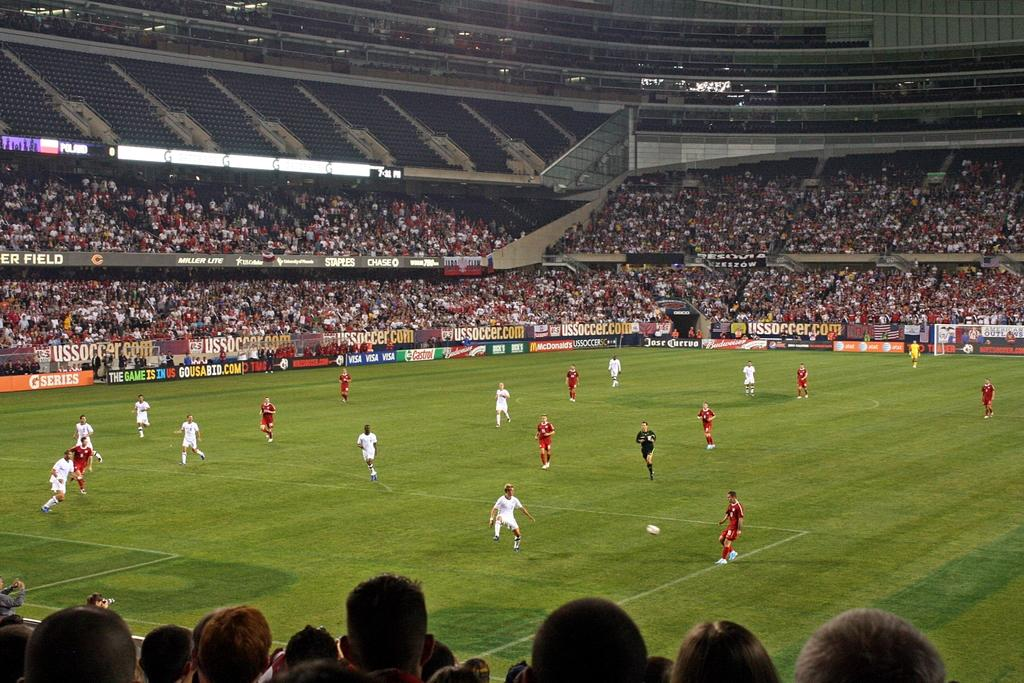<image>
Describe the image concisely. soccer game inside stadium with sponsor signs for ussoccer.com, castrol oil, budweiser, and at&t 